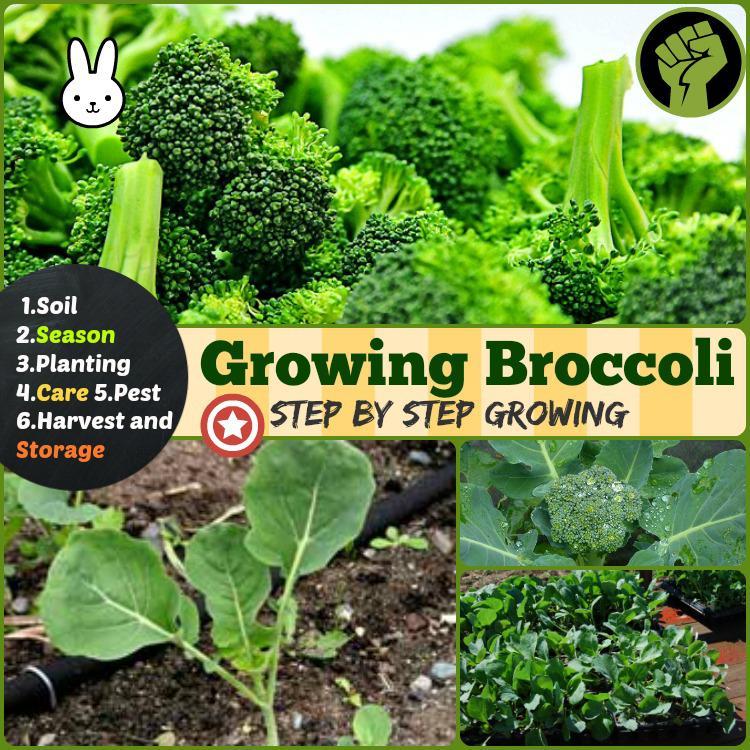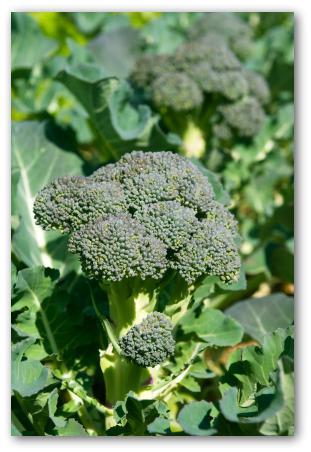The first image is the image on the left, the second image is the image on the right. Examine the images to the left and right. Is the description "There is fresh broccoli in a field." accurate? Answer yes or no. Yes. 